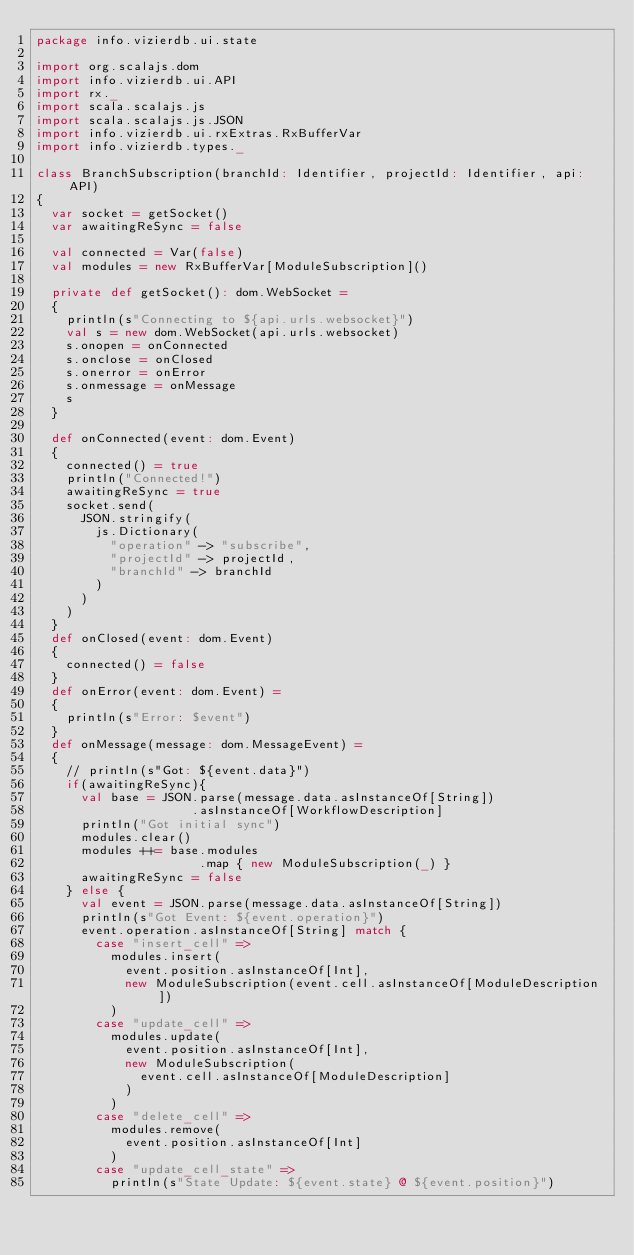<code> <loc_0><loc_0><loc_500><loc_500><_Scala_>package info.vizierdb.ui.state

import org.scalajs.dom
import info.vizierdb.ui.API
import rx._
import scala.scalajs.js
import scala.scalajs.js.JSON
import info.vizierdb.ui.rxExtras.RxBufferVar
import info.vizierdb.types._

class BranchSubscription(branchId: Identifier, projectId: Identifier, api: API)
{
  var socket = getSocket() 
  var awaitingReSync = false

  val connected = Var(false)
  val modules = new RxBufferVar[ModuleSubscription]()

  private def getSocket(): dom.WebSocket =
  {
    println(s"Connecting to ${api.urls.websocket}")
    val s = new dom.WebSocket(api.urls.websocket)
    s.onopen = onConnected
    s.onclose = onClosed
    s.onerror = onError
    s.onmessage = onMessage
    s
  }

  def onConnected(event: dom.Event)
  {
    connected() = true
    println("Connected!")
    awaitingReSync = true
    socket.send(
      JSON.stringify(
        js.Dictionary(
          "operation" -> "subscribe",
          "projectId" -> projectId,
          "branchId" -> branchId
        )
      )
    )
  }
  def onClosed(event: dom.Event)
  {
    connected() = false
  }
  def onError(event: dom.Event) = 
  {
    println(s"Error: $event")
  }
  def onMessage(message: dom.MessageEvent) =
  {
    // println(s"Got: ${event.data}")
    if(awaitingReSync){
      val base = JSON.parse(message.data.asInstanceOf[String])
                     .asInstanceOf[WorkflowDescription]
      println("Got initial sync")
      modules.clear()
      modules ++= base.modules
                      .map { new ModuleSubscription(_) }
      awaitingReSync = false
    } else {
      val event = JSON.parse(message.data.asInstanceOf[String])
      println(s"Got Event: ${event.operation}")
      event.operation.asInstanceOf[String] match {
        case "insert_cell" => 
          modules.insert(
            event.position.asInstanceOf[Int],
            new ModuleSubscription(event.cell.asInstanceOf[ModuleDescription])
          )
        case "update_cell" => 
          modules.update(
            event.position.asInstanceOf[Int],
            new ModuleSubscription(
              event.cell.asInstanceOf[ModuleDescription]
            )
          )
        case "delete_cell" => 
          modules.remove(
            event.position.asInstanceOf[Int]
          )
        case "update_cell_state" =>
          println(s"State Update: ${event.state} @ ${event.position}")</code> 